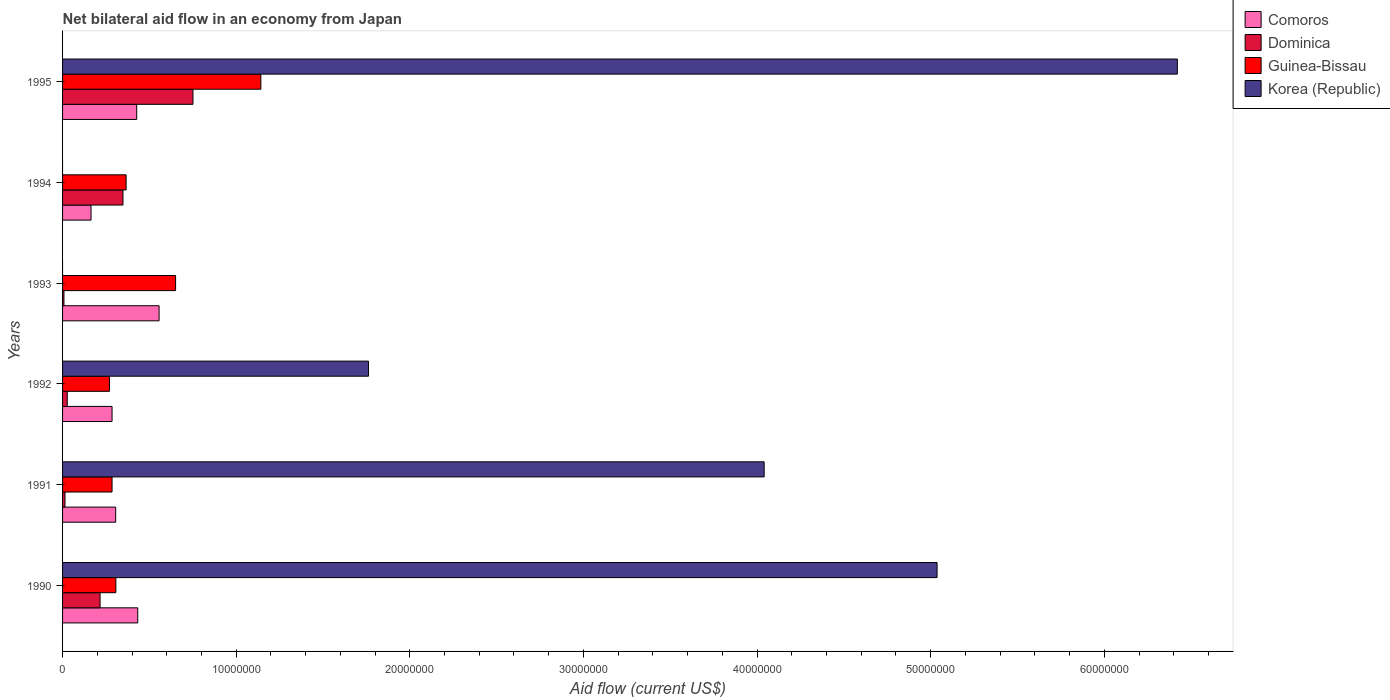Are the number of bars on each tick of the Y-axis equal?
Ensure brevity in your answer.  No. What is the label of the 1st group of bars from the top?
Offer a terse response. 1995. What is the net bilateral aid flow in Korea (Republic) in 1992?
Provide a short and direct response. 1.76e+07. Across all years, what is the maximum net bilateral aid flow in Comoros?
Your answer should be compact. 5.56e+06. In which year was the net bilateral aid flow in Comoros maximum?
Provide a short and direct response. 1993. What is the total net bilateral aid flow in Guinea-Bissau in the graph?
Make the answer very short. 3.02e+07. What is the difference between the net bilateral aid flow in Comoros in 1990 and that in 1993?
Keep it short and to the point. -1.23e+06. What is the difference between the net bilateral aid flow in Comoros in 1992 and the net bilateral aid flow in Dominica in 1994?
Your answer should be very brief. -6.30e+05. What is the average net bilateral aid flow in Guinea-Bissau per year?
Give a very brief answer. 5.04e+06. In the year 1991, what is the difference between the net bilateral aid flow in Dominica and net bilateral aid flow in Guinea-Bissau?
Give a very brief answer. -2.71e+06. What is the ratio of the net bilateral aid flow in Guinea-Bissau in 1991 to that in 1995?
Give a very brief answer. 0.25. Is the net bilateral aid flow in Comoros in 1992 less than that in 1993?
Offer a terse response. Yes. Is the difference between the net bilateral aid flow in Dominica in 1992 and 1995 greater than the difference between the net bilateral aid flow in Guinea-Bissau in 1992 and 1995?
Keep it short and to the point. Yes. What is the difference between the highest and the second highest net bilateral aid flow in Dominica?
Offer a terse response. 4.03e+06. What is the difference between the highest and the lowest net bilateral aid flow in Guinea-Bissau?
Give a very brief answer. 8.72e+06. In how many years, is the net bilateral aid flow in Dominica greater than the average net bilateral aid flow in Dominica taken over all years?
Ensure brevity in your answer.  2. How many bars are there?
Your response must be concise. 22. What is the difference between two consecutive major ticks on the X-axis?
Provide a succinct answer. 1.00e+07. Does the graph contain grids?
Your answer should be very brief. No. How many legend labels are there?
Your answer should be very brief. 4. What is the title of the graph?
Provide a short and direct response. Net bilateral aid flow in an economy from Japan. What is the label or title of the Y-axis?
Offer a terse response. Years. What is the Aid flow (current US$) in Comoros in 1990?
Your answer should be compact. 4.33e+06. What is the Aid flow (current US$) of Dominica in 1990?
Ensure brevity in your answer.  2.16e+06. What is the Aid flow (current US$) in Guinea-Bissau in 1990?
Keep it short and to the point. 3.07e+06. What is the Aid flow (current US$) of Korea (Republic) in 1990?
Your answer should be very brief. 5.04e+07. What is the Aid flow (current US$) of Comoros in 1991?
Ensure brevity in your answer.  3.06e+06. What is the Aid flow (current US$) of Dominica in 1991?
Provide a short and direct response. 1.40e+05. What is the Aid flow (current US$) of Guinea-Bissau in 1991?
Provide a short and direct response. 2.85e+06. What is the Aid flow (current US$) in Korea (Republic) in 1991?
Offer a terse response. 4.04e+07. What is the Aid flow (current US$) of Comoros in 1992?
Provide a succinct answer. 2.85e+06. What is the Aid flow (current US$) in Guinea-Bissau in 1992?
Make the answer very short. 2.70e+06. What is the Aid flow (current US$) in Korea (Republic) in 1992?
Provide a short and direct response. 1.76e+07. What is the Aid flow (current US$) in Comoros in 1993?
Your response must be concise. 5.56e+06. What is the Aid flow (current US$) of Dominica in 1993?
Provide a succinct answer. 8.00e+04. What is the Aid flow (current US$) in Guinea-Bissau in 1993?
Provide a short and direct response. 6.51e+06. What is the Aid flow (current US$) in Comoros in 1994?
Keep it short and to the point. 1.64e+06. What is the Aid flow (current US$) in Dominica in 1994?
Your answer should be compact. 3.48e+06. What is the Aid flow (current US$) in Guinea-Bissau in 1994?
Your answer should be compact. 3.66e+06. What is the Aid flow (current US$) in Comoros in 1995?
Provide a short and direct response. 4.27e+06. What is the Aid flow (current US$) in Dominica in 1995?
Keep it short and to the point. 7.51e+06. What is the Aid flow (current US$) in Guinea-Bissau in 1995?
Ensure brevity in your answer.  1.14e+07. What is the Aid flow (current US$) of Korea (Republic) in 1995?
Offer a terse response. 6.42e+07. Across all years, what is the maximum Aid flow (current US$) of Comoros?
Give a very brief answer. 5.56e+06. Across all years, what is the maximum Aid flow (current US$) of Dominica?
Your response must be concise. 7.51e+06. Across all years, what is the maximum Aid flow (current US$) in Guinea-Bissau?
Make the answer very short. 1.14e+07. Across all years, what is the maximum Aid flow (current US$) of Korea (Republic)?
Ensure brevity in your answer.  6.42e+07. Across all years, what is the minimum Aid flow (current US$) of Comoros?
Make the answer very short. 1.64e+06. Across all years, what is the minimum Aid flow (current US$) of Dominica?
Keep it short and to the point. 8.00e+04. Across all years, what is the minimum Aid flow (current US$) of Guinea-Bissau?
Ensure brevity in your answer.  2.70e+06. Across all years, what is the minimum Aid flow (current US$) of Korea (Republic)?
Provide a succinct answer. 0. What is the total Aid flow (current US$) of Comoros in the graph?
Offer a terse response. 2.17e+07. What is the total Aid flow (current US$) in Dominica in the graph?
Provide a succinct answer. 1.36e+07. What is the total Aid flow (current US$) in Guinea-Bissau in the graph?
Offer a terse response. 3.02e+07. What is the total Aid flow (current US$) of Korea (Republic) in the graph?
Your response must be concise. 1.73e+08. What is the difference between the Aid flow (current US$) in Comoros in 1990 and that in 1991?
Make the answer very short. 1.27e+06. What is the difference between the Aid flow (current US$) of Dominica in 1990 and that in 1991?
Your response must be concise. 2.02e+06. What is the difference between the Aid flow (current US$) of Guinea-Bissau in 1990 and that in 1991?
Give a very brief answer. 2.20e+05. What is the difference between the Aid flow (current US$) of Korea (Republic) in 1990 and that in 1991?
Offer a terse response. 9.96e+06. What is the difference between the Aid flow (current US$) of Comoros in 1990 and that in 1992?
Ensure brevity in your answer.  1.48e+06. What is the difference between the Aid flow (current US$) of Dominica in 1990 and that in 1992?
Keep it short and to the point. 1.89e+06. What is the difference between the Aid flow (current US$) of Guinea-Bissau in 1990 and that in 1992?
Provide a succinct answer. 3.70e+05. What is the difference between the Aid flow (current US$) of Korea (Republic) in 1990 and that in 1992?
Provide a short and direct response. 3.28e+07. What is the difference between the Aid flow (current US$) in Comoros in 1990 and that in 1993?
Ensure brevity in your answer.  -1.23e+06. What is the difference between the Aid flow (current US$) in Dominica in 1990 and that in 1993?
Offer a very short reply. 2.08e+06. What is the difference between the Aid flow (current US$) in Guinea-Bissau in 1990 and that in 1993?
Your response must be concise. -3.44e+06. What is the difference between the Aid flow (current US$) of Comoros in 1990 and that in 1994?
Make the answer very short. 2.69e+06. What is the difference between the Aid flow (current US$) in Dominica in 1990 and that in 1994?
Offer a terse response. -1.32e+06. What is the difference between the Aid flow (current US$) in Guinea-Bissau in 1990 and that in 1994?
Offer a terse response. -5.90e+05. What is the difference between the Aid flow (current US$) of Dominica in 1990 and that in 1995?
Provide a succinct answer. -5.35e+06. What is the difference between the Aid flow (current US$) in Guinea-Bissau in 1990 and that in 1995?
Offer a terse response. -8.35e+06. What is the difference between the Aid flow (current US$) of Korea (Republic) in 1990 and that in 1995?
Your answer should be compact. -1.38e+07. What is the difference between the Aid flow (current US$) in Comoros in 1991 and that in 1992?
Your response must be concise. 2.10e+05. What is the difference between the Aid flow (current US$) of Korea (Republic) in 1991 and that in 1992?
Your answer should be compact. 2.28e+07. What is the difference between the Aid flow (current US$) in Comoros in 1991 and that in 1993?
Your answer should be compact. -2.50e+06. What is the difference between the Aid flow (current US$) of Dominica in 1991 and that in 1993?
Your answer should be very brief. 6.00e+04. What is the difference between the Aid flow (current US$) of Guinea-Bissau in 1991 and that in 1993?
Keep it short and to the point. -3.66e+06. What is the difference between the Aid flow (current US$) of Comoros in 1991 and that in 1994?
Provide a short and direct response. 1.42e+06. What is the difference between the Aid flow (current US$) of Dominica in 1991 and that in 1994?
Your answer should be compact. -3.34e+06. What is the difference between the Aid flow (current US$) in Guinea-Bissau in 1991 and that in 1994?
Make the answer very short. -8.10e+05. What is the difference between the Aid flow (current US$) of Comoros in 1991 and that in 1995?
Offer a very short reply. -1.21e+06. What is the difference between the Aid flow (current US$) of Dominica in 1991 and that in 1995?
Ensure brevity in your answer.  -7.37e+06. What is the difference between the Aid flow (current US$) in Guinea-Bissau in 1991 and that in 1995?
Offer a very short reply. -8.57e+06. What is the difference between the Aid flow (current US$) in Korea (Republic) in 1991 and that in 1995?
Offer a very short reply. -2.38e+07. What is the difference between the Aid flow (current US$) of Comoros in 1992 and that in 1993?
Make the answer very short. -2.71e+06. What is the difference between the Aid flow (current US$) of Dominica in 1992 and that in 1993?
Offer a terse response. 1.90e+05. What is the difference between the Aid flow (current US$) of Guinea-Bissau in 1992 and that in 1993?
Provide a short and direct response. -3.81e+06. What is the difference between the Aid flow (current US$) in Comoros in 1992 and that in 1994?
Provide a short and direct response. 1.21e+06. What is the difference between the Aid flow (current US$) of Dominica in 1992 and that in 1994?
Make the answer very short. -3.21e+06. What is the difference between the Aid flow (current US$) in Guinea-Bissau in 1992 and that in 1994?
Your response must be concise. -9.60e+05. What is the difference between the Aid flow (current US$) of Comoros in 1992 and that in 1995?
Your answer should be very brief. -1.42e+06. What is the difference between the Aid flow (current US$) in Dominica in 1992 and that in 1995?
Provide a succinct answer. -7.24e+06. What is the difference between the Aid flow (current US$) in Guinea-Bissau in 1992 and that in 1995?
Offer a very short reply. -8.72e+06. What is the difference between the Aid flow (current US$) of Korea (Republic) in 1992 and that in 1995?
Offer a very short reply. -4.66e+07. What is the difference between the Aid flow (current US$) in Comoros in 1993 and that in 1994?
Keep it short and to the point. 3.92e+06. What is the difference between the Aid flow (current US$) of Dominica in 1993 and that in 1994?
Your response must be concise. -3.40e+06. What is the difference between the Aid flow (current US$) of Guinea-Bissau in 1993 and that in 1994?
Provide a succinct answer. 2.85e+06. What is the difference between the Aid flow (current US$) of Comoros in 1993 and that in 1995?
Provide a short and direct response. 1.29e+06. What is the difference between the Aid flow (current US$) of Dominica in 1993 and that in 1995?
Provide a succinct answer. -7.43e+06. What is the difference between the Aid flow (current US$) of Guinea-Bissau in 1993 and that in 1995?
Offer a very short reply. -4.91e+06. What is the difference between the Aid flow (current US$) in Comoros in 1994 and that in 1995?
Provide a short and direct response. -2.63e+06. What is the difference between the Aid flow (current US$) in Dominica in 1994 and that in 1995?
Provide a succinct answer. -4.03e+06. What is the difference between the Aid flow (current US$) in Guinea-Bissau in 1994 and that in 1995?
Provide a short and direct response. -7.76e+06. What is the difference between the Aid flow (current US$) in Comoros in 1990 and the Aid flow (current US$) in Dominica in 1991?
Ensure brevity in your answer.  4.19e+06. What is the difference between the Aid flow (current US$) in Comoros in 1990 and the Aid flow (current US$) in Guinea-Bissau in 1991?
Give a very brief answer. 1.48e+06. What is the difference between the Aid flow (current US$) in Comoros in 1990 and the Aid flow (current US$) in Korea (Republic) in 1991?
Provide a short and direct response. -3.61e+07. What is the difference between the Aid flow (current US$) in Dominica in 1990 and the Aid flow (current US$) in Guinea-Bissau in 1991?
Provide a succinct answer. -6.90e+05. What is the difference between the Aid flow (current US$) of Dominica in 1990 and the Aid flow (current US$) of Korea (Republic) in 1991?
Provide a succinct answer. -3.82e+07. What is the difference between the Aid flow (current US$) in Guinea-Bissau in 1990 and the Aid flow (current US$) in Korea (Republic) in 1991?
Offer a very short reply. -3.73e+07. What is the difference between the Aid flow (current US$) in Comoros in 1990 and the Aid flow (current US$) in Dominica in 1992?
Your answer should be compact. 4.06e+06. What is the difference between the Aid flow (current US$) in Comoros in 1990 and the Aid flow (current US$) in Guinea-Bissau in 1992?
Provide a short and direct response. 1.63e+06. What is the difference between the Aid flow (current US$) in Comoros in 1990 and the Aid flow (current US$) in Korea (Republic) in 1992?
Provide a succinct answer. -1.33e+07. What is the difference between the Aid flow (current US$) in Dominica in 1990 and the Aid flow (current US$) in Guinea-Bissau in 1992?
Provide a succinct answer. -5.40e+05. What is the difference between the Aid flow (current US$) of Dominica in 1990 and the Aid flow (current US$) of Korea (Republic) in 1992?
Make the answer very short. -1.55e+07. What is the difference between the Aid flow (current US$) of Guinea-Bissau in 1990 and the Aid flow (current US$) of Korea (Republic) in 1992?
Make the answer very short. -1.46e+07. What is the difference between the Aid flow (current US$) in Comoros in 1990 and the Aid flow (current US$) in Dominica in 1993?
Your answer should be compact. 4.25e+06. What is the difference between the Aid flow (current US$) of Comoros in 1990 and the Aid flow (current US$) of Guinea-Bissau in 1993?
Keep it short and to the point. -2.18e+06. What is the difference between the Aid flow (current US$) of Dominica in 1990 and the Aid flow (current US$) of Guinea-Bissau in 1993?
Your answer should be compact. -4.35e+06. What is the difference between the Aid flow (current US$) of Comoros in 1990 and the Aid flow (current US$) of Dominica in 1994?
Keep it short and to the point. 8.50e+05. What is the difference between the Aid flow (current US$) of Comoros in 1990 and the Aid flow (current US$) of Guinea-Bissau in 1994?
Make the answer very short. 6.70e+05. What is the difference between the Aid flow (current US$) in Dominica in 1990 and the Aid flow (current US$) in Guinea-Bissau in 1994?
Make the answer very short. -1.50e+06. What is the difference between the Aid flow (current US$) of Comoros in 1990 and the Aid flow (current US$) of Dominica in 1995?
Your answer should be very brief. -3.18e+06. What is the difference between the Aid flow (current US$) in Comoros in 1990 and the Aid flow (current US$) in Guinea-Bissau in 1995?
Ensure brevity in your answer.  -7.09e+06. What is the difference between the Aid flow (current US$) in Comoros in 1990 and the Aid flow (current US$) in Korea (Republic) in 1995?
Provide a short and direct response. -5.99e+07. What is the difference between the Aid flow (current US$) in Dominica in 1990 and the Aid flow (current US$) in Guinea-Bissau in 1995?
Offer a very short reply. -9.26e+06. What is the difference between the Aid flow (current US$) in Dominica in 1990 and the Aid flow (current US$) in Korea (Republic) in 1995?
Your response must be concise. -6.20e+07. What is the difference between the Aid flow (current US$) in Guinea-Bissau in 1990 and the Aid flow (current US$) in Korea (Republic) in 1995?
Provide a succinct answer. -6.11e+07. What is the difference between the Aid flow (current US$) in Comoros in 1991 and the Aid flow (current US$) in Dominica in 1992?
Make the answer very short. 2.79e+06. What is the difference between the Aid flow (current US$) of Comoros in 1991 and the Aid flow (current US$) of Guinea-Bissau in 1992?
Your answer should be compact. 3.60e+05. What is the difference between the Aid flow (current US$) of Comoros in 1991 and the Aid flow (current US$) of Korea (Republic) in 1992?
Offer a very short reply. -1.46e+07. What is the difference between the Aid flow (current US$) in Dominica in 1991 and the Aid flow (current US$) in Guinea-Bissau in 1992?
Ensure brevity in your answer.  -2.56e+06. What is the difference between the Aid flow (current US$) in Dominica in 1991 and the Aid flow (current US$) in Korea (Republic) in 1992?
Offer a very short reply. -1.75e+07. What is the difference between the Aid flow (current US$) of Guinea-Bissau in 1991 and the Aid flow (current US$) of Korea (Republic) in 1992?
Ensure brevity in your answer.  -1.48e+07. What is the difference between the Aid flow (current US$) in Comoros in 1991 and the Aid flow (current US$) in Dominica in 1993?
Your answer should be very brief. 2.98e+06. What is the difference between the Aid flow (current US$) of Comoros in 1991 and the Aid flow (current US$) of Guinea-Bissau in 1993?
Provide a succinct answer. -3.45e+06. What is the difference between the Aid flow (current US$) of Dominica in 1991 and the Aid flow (current US$) of Guinea-Bissau in 1993?
Give a very brief answer. -6.37e+06. What is the difference between the Aid flow (current US$) of Comoros in 1991 and the Aid flow (current US$) of Dominica in 1994?
Keep it short and to the point. -4.20e+05. What is the difference between the Aid flow (current US$) of Comoros in 1991 and the Aid flow (current US$) of Guinea-Bissau in 1994?
Provide a short and direct response. -6.00e+05. What is the difference between the Aid flow (current US$) in Dominica in 1991 and the Aid flow (current US$) in Guinea-Bissau in 1994?
Give a very brief answer. -3.52e+06. What is the difference between the Aid flow (current US$) of Comoros in 1991 and the Aid flow (current US$) of Dominica in 1995?
Your answer should be compact. -4.45e+06. What is the difference between the Aid flow (current US$) of Comoros in 1991 and the Aid flow (current US$) of Guinea-Bissau in 1995?
Make the answer very short. -8.36e+06. What is the difference between the Aid flow (current US$) of Comoros in 1991 and the Aid flow (current US$) of Korea (Republic) in 1995?
Ensure brevity in your answer.  -6.12e+07. What is the difference between the Aid flow (current US$) of Dominica in 1991 and the Aid flow (current US$) of Guinea-Bissau in 1995?
Offer a terse response. -1.13e+07. What is the difference between the Aid flow (current US$) in Dominica in 1991 and the Aid flow (current US$) in Korea (Republic) in 1995?
Your answer should be compact. -6.41e+07. What is the difference between the Aid flow (current US$) in Guinea-Bissau in 1991 and the Aid flow (current US$) in Korea (Republic) in 1995?
Make the answer very short. -6.14e+07. What is the difference between the Aid flow (current US$) in Comoros in 1992 and the Aid flow (current US$) in Dominica in 1993?
Keep it short and to the point. 2.77e+06. What is the difference between the Aid flow (current US$) in Comoros in 1992 and the Aid flow (current US$) in Guinea-Bissau in 1993?
Offer a very short reply. -3.66e+06. What is the difference between the Aid flow (current US$) of Dominica in 1992 and the Aid flow (current US$) of Guinea-Bissau in 1993?
Provide a succinct answer. -6.24e+06. What is the difference between the Aid flow (current US$) in Comoros in 1992 and the Aid flow (current US$) in Dominica in 1994?
Offer a very short reply. -6.30e+05. What is the difference between the Aid flow (current US$) of Comoros in 1992 and the Aid flow (current US$) of Guinea-Bissau in 1994?
Ensure brevity in your answer.  -8.10e+05. What is the difference between the Aid flow (current US$) of Dominica in 1992 and the Aid flow (current US$) of Guinea-Bissau in 1994?
Offer a very short reply. -3.39e+06. What is the difference between the Aid flow (current US$) of Comoros in 1992 and the Aid flow (current US$) of Dominica in 1995?
Provide a short and direct response. -4.66e+06. What is the difference between the Aid flow (current US$) of Comoros in 1992 and the Aid flow (current US$) of Guinea-Bissau in 1995?
Provide a succinct answer. -8.57e+06. What is the difference between the Aid flow (current US$) of Comoros in 1992 and the Aid flow (current US$) of Korea (Republic) in 1995?
Offer a terse response. -6.14e+07. What is the difference between the Aid flow (current US$) in Dominica in 1992 and the Aid flow (current US$) in Guinea-Bissau in 1995?
Keep it short and to the point. -1.12e+07. What is the difference between the Aid flow (current US$) of Dominica in 1992 and the Aid flow (current US$) of Korea (Republic) in 1995?
Provide a succinct answer. -6.39e+07. What is the difference between the Aid flow (current US$) in Guinea-Bissau in 1992 and the Aid flow (current US$) in Korea (Republic) in 1995?
Keep it short and to the point. -6.15e+07. What is the difference between the Aid flow (current US$) in Comoros in 1993 and the Aid flow (current US$) in Dominica in 1994?
Provide a succinct answer. 2.08e+06. What is the difference between the Aid flow (current US$) in Comoros in 1993 and the Aid flow (current US$) in Guinea-Bissau in 1994?
Offer a terse response. 1.90e+06. What is the difference between the Aid flow (current US$) of Dominica in 1993 and the Aid flow (current US$) of Guinea-Bissau in 1994?
Provide a short and direct response. -3.58e+06. What is the difference between the Aid flow (current US$) in Comoros in 1993 and the Aid flow (current US$) in Dominica in 1995?
Your answer should be very brief. -1.95e+06. What is the difference between the Aid flow (current US$) of Comoros in 1993 and the Aid flow (current US$) of Guinea-Bissau in 1995?
Your answer should be compact. -5.86e+06. What is the difference between the Aid flow (current US$) of Comoros in 1993 and the Aid flow (current US$) of Korea (Republic) in 1995?
Your answer should be very brief. -5.86e+07. What is the difference between the Aid flow (current US$) of Dominica in 1993 and the Aid flow (current US$) of Guinea-Bissau in 1995?
Offer a very short reply. -1.13e+07. What is the difference between the Aid flow (current US$) in Dominica in 1993 and the Aid flow (current US$) in Korea (Republic) in 1995?
Your answer should be very brief. -6.41e+07. What is the difference between the Aid flow (current US$) of Guinea-Bissau in 1993 and the Aid flow (current US$) of Korea (Republic) in 1995?
Your response must be concise. -5.77e+07. What is the difference between the Aid flow (current US$) in Comoros in 1994 and the Aid flow (current US$) in Dominica in 1995?
Provide a short and direct response. -5.87e+06. What is the difference between the Aid flow (current US$) in Comoros in 1994 and the Aid flow (current US$) in Guinea-Bissau in 1995?
Your response must be concise. -9.78e+06. What is the difference between the Aid flow (current US$) of Comoros in 1994 and the Aid flow (current US$) of Korea (Republic) in 1995?
Your response must be concise. -6.26e+07. What is the difference between the Aid flow (current US$) of Dominica in 1994 and the Aid flow (current US$) of Guinea-Bissau in 1995?
Provide a short and direct response. -7.94e+06. What is the difference between the Aid flow (current US$) of Dominica in 1994 and the Aid flow (current US$) of Korea (Republic) in 1995?
Make the answer very short. -6.07e+07. What is the difference between the Aid flow (current US$) in Guinea-Bissau in 1994 and the Aid flow (current US$) in Korea (Republic) in 1995?
Offer a very short reply. -6.06e+07. What is the average Aid flow (current US$) of Comoros per year?
Your answer should be very brief. 3.62e+06. What is the average Aid flow (current US$) of Dominica per year?
Provide a short and direct response. 2.27e+06. What is the average Aid flow (current US$) in Guinea-Bissau per year?
Give a very brief answer. 5.04e+06. What is the average Aid flow (current US$) in Korea (Republic) per year?
Keep it short and to the point. 2.88e+07. In the year 1990, what is the difference between the Aid flow (current US$) of Comoros and Aid flow (current US$) of Dominica?
Keep it short and to the point. 2.17e+06. In the year 1990, what is the difference between the Aid flow (current US$) in Comoros and Aid flow (current US$) in Guinea-Bissau?
Make the answer very short. 1.26e+06. In the year 1990, what is the difference between the Aid flow (current US$) in Comoros and Aid flow (current US$) in Korea (Republic)?
Offer a very short reply. -4.60e+07. In the year 1990, what is the difference between the Aid flow (current US$) in Dominica and Aid flow (current US$) in Guinea-Bissau?
Make the answer very short. -9.10e+05. In the year 1990, what is the difference between the Aid flow (current US$) in Dominica and Aid flow (current US$) in Korea (Republic)?
Offer a terse response. -4.82e+07. In the year 1990, what is the difference between the Aid flow (current US$) in Guinea-Bissau and Aid flow (current US$) in Korea (Republic)?
Your response must be concise. -4.73e+07. In the year 1991, what is the difference between the Aid flow (current US$) of Comoros and Aid flow (current US$) of Dominica?
Offer a very short reply. 2.92e+06. In the year 1991, what is the difference between the Aid flow (current US$) in Comoros and Aid flow (current US$) in Guinea-Bissau?
Provide a succinct answer. 2.10e+05. In the year 1991, what is the difference between the Aid flow (current US$) of Comoros and Aid flow (current US$) of Korea (Republic)?
Offer a terse response. -3.74e+07. In the year 1991, what is the difference between the Aid flow (current US$) of Dominica and Aid flow (current US$) of Guinea-Bissau?
Your answer should be compact. -2.71e+06. In the year 1991, what is the difference between the Aid flow (current US$) of Dominica and Aid flow (current US$) of Korea (Republic)?
Keep it short and to the point. -4.03e+07. In the year 1991, what is the difference between the Aid flow (current US$) of Guinea-Bissau and Aid flow (current US$) of Korea (Republic)?
Provide a succinct answer. -3.76e+07. In the year 1992, what is the difference between the Aid flow (current US$) of Comoros and Aid flow (current US$) of Dominica?
Your response must be concise. 2.58e+06. In the year 1992, what is the difference between the Aid flow (current US$) in Comoros and Aid flow (current US$) in Guinea-Bissau?
Your answer should be compact. 1.50e+05. In the year 1992, what is the difference between the Aid flow (current US$) in Comoros and Aid flow (current US$) in Korea (Republic)?
Ensure brevity in your answer.  -1.48e+07. In the year 1992, what is the difference between the Aid flow (current US$) in Dominica and Aid flow (current US$) in Guinea-Bissau?
Give a very brief answer. -2.43e+06. In the year 1992, what is the difference between the Aid flow (current US$) in Dominica and Aid flow (current US$) in Korea (Republic)?
Ensure brevity in your answer.  -1.74e+07. In the year 1992, what is the difference between the Aid flow (current US$) in Guinea-Bissau and Aid flow (current US$) in Korea (Republic)?
Offer a very short reply. -1.49e+07. In the year 1993, what is the difference between the Aid flow (current US$) in Comoros and Aid flow (current US$) in Dominica?
Make the answer very short. 5.48e+06. In the year 1993, what is the difference between the Aid flow (current US$) of Comoros and Aid flow (current US$) of Guinea-Bissau?
Provide a short and direct response. -9.50e+05. In the year 1993, what is the difference between the Aid flow (current US$) in Dominica and Aid flow (current US$) in Guinea-Bissau?
Give a very brief answer. -6.43e+06. In the year 1994, what is the difference between the Aid flow (current US$) in Comoros and Aid flow (current US$) in Dominica?
Provide a short and direct response. -1.84e+06. In the year 1994, what is the difference between the Aid flow (current US$) of Comoros and Aid flow (current US$) of Guinea-Bissau?
Your response must be concise. -2.02e+06. In the year 1995, what is the difference between the Aid flow (current US$) in Comoros and Aid flow (current US$) in Dominica?
Provide a short and direct response. -3.24e+06. In the year 1995, what is the difference between the Aid flow (current US$) in Comoros and Aid flow (current US$) in Guinea-Bissau?
Make the answer very short. -7.15e+06. In the year 1995, what is the difference between the Aid flow (current US$) in Comoros and Aid flow (current US$) in Korea (Republic)?
Give a very brief answer. -5.99e+07. In the year 1995, what is the difference between the Aid flow (current US$) in Dominica and Aid flow (current US$) in Guinea-Bissau?
Provide a short and direct response. -3.91e+06. In the year 1995, what is the difference between the Aid flow (current US$) of Dominica and Aid flow (current US$) of Korea (Republic)?
Provide a short and direct response. -5.67e+07. In the year 1995, what is the difference between the Aid flow (current US$) of Guinea-Bissau and Aid flow (current US$) of Korea (Republic)?
Offer a terse response. -5.28e+07. What is the ratio of the Aid flow (current US$) in Comoros in 1990 to that in 1991?
Offer a terse response. 1.42. What is the ratio of the Aid flow (current US$) in Dominica in 1990 to that in 1991?
Your answer should be very brief. 15.43. What is the ratio of the Aid flow (current US$) of Guinea-Bissau in 1990 to that in 1991?
Offer a very short reply. 1.08. What is the ratio of the Aid flow (current US$) in Korea (Republic) in 1990 to that in 1991?
Your answer should be very brief. 1.25. What is the ratio of the Aid flow (current US$) of Comoros in 1990 to that in 1992?
Offer a terse response. 1.52. What is the ratio of the Aid flow (current US$) of Guinea-Bissau in 1990 to that in 1992?
Your answer should be very brief. 1.14. What is the ratio of the Aid flow (current US$) of Korea (Republic) in 1990 to that in 1992?
Keep it short and to the point. 2.86. What is the ratio of the Aid flow (current US$) in Comoros in 1990 to that in 1993?
Your answer should be very brief. 0.78. What is the ratio of the Aid flow (current US$) in Dominica in 1990 to that in 1993?
Make the answer very short. 27. What is the ratio of the Aid flow (current US$) in Guinea-Bissau in 1990 to that in 1993?
Give a very brief answer. 0.47. What is the ratio of the Aid flow (current US$) of Comoros in 1990 to that in 1994?
Provide a short and direct response. 2.64. What is the ratio of the Aid flow (current US$) of Dominica in 1990 to that in 1994?
Offer a very short reply. 0.62. What is the ratio of the Aid flow (current US$) in Guinea-Bissau in 1990 to that in 1994?
Make the answer very short. 0.84. What is the ratio of the Aid flow (current US$) in Comoros in 1990 to that in 1995?
Provide a succinct answer. 1.01. What is the ratio of the Aid flow (current US$) of Dominica in 1990 to that in 1995?
Provide a succinct answer. 0.29. What is the ratio of the Aid flow (current US$) in Guinea-Bissau in 1990 to that in 1995?
Give a very brief answer. 0.27. What is the ratio of the Aid flow (current US$) of Korea (Republic) in 1990 to that in 1995?
Give a very brief answer. 0.78. What is the ratio of the Aid flow (current US$) in Comoros in 1991 to that in 1992?
Your response must be concise. 1.07. What is the ratio of the Aid flow (current US$) of Dominica in 1991 to that in 1992?
Give a very brief answer. 0.52. What is the ratio of the Aid flow (current US$) of Guinea-Bissau in 1991 to that in 1992?
Your answer should be compact. 1.06. What is the ratio of the Aid flow (current US$) in Korea (Republic) in 1991 to that in 1992?
Your answer should be very brief. 2.29. What is the ratio of the Aid flow (current US$) of Comoros in 1991 to that in 1993?
Ensure brevity in your answer.  0.55. What is the ratio of the Aid flow (current US$) in Dominica in 1991 to that in 1993?
Provide a short and direct response. 1.75. What is the ratio of the Aid flow (current US$) in Guinea-Bissau in 1991 to that in 1993?
Provide a succinct answer. 0.44. What is the ratio of the Aid flow (current US$) of Comoros in 1991 to that in 1994?
Offer a terse response. 1.87. What is the ratio of the Aid flow (current US$) in Dominica in 1991 to that in 1994?
Provide a succinct answer. 0.04. What is the ratio of the Aid flow (current US$) in Guinea-Bissau in 1991 to that in 1994?
Provide a short and direct response. 0.78. What is the ratio of the Aid flow (current US$) in Comoros in 1991 to that in 1995?
Make the answer very short. 0.72. What is the ratio of the Aid flow (current US$) of Dominica in 1991 to that in 1995?
Offer a terse response. 0.02. What is the ratio of the Aid flow (current US$) in Guinea-Bissau in 1991 to that in 1995?
Keep it short and to the point. 0.25. What is the ratio of the Aid flow (current US$) of Korea (Republic) in 1991 to that in 1995?
Your response must be concise. 0.63. What is the ratio of the Aid flow (current US$) in Comoros in 1992 to that in 1993?
Ensure brevity in your answer.  0.51. What is the ratio of the Aid flow (current US$) of Dominica in 1992 to that in 1993?
Provide a succinct answer. 3.38. What is the ratio of the Aid flow (current US$) in Guinea-Bissau in 1992 to that in 1993?
Make the answer very short. 0.41. What is the ratio of the Aid flow (current US$) in Comoros in 1992 to that in 1994?
Provide a succinct answer. 1.74. What is the ratio of the Aid flow (current US$) in Dominica in 1992 to that in 1994?
Provide a short and direct response. 0.08. What is the ratio of the Aid flow (current US$) in Guinea-Bissau in 1992 to that in 1994?
Provide a succinct answer. 0.74. What is the ratio of the Aid flow (current US$) in Comoros in 1992 to that in 1995?
Provide a succinct answer. 0.67. What is the ratio of the Aid flow (current US$) of Dominica in 1992 to that in 1995?
Offer a terse response. 0.04. What is the ratio of the Aid flow (current US$) of Guinea-Bissau in 1992 to that in 1995?
Provide a succinct answer. 0.24. What is the ratio of the Aid flow (current US$) of Korea (Republic) in 1992 to that in 1995?
Ensure brevity in your answer.  0.27. What is the ratio of the Aid flow (current US$) in Comoros in 1993 to that in 1994?
Your answer should be very brief. 3.39. What is the ratio of the Aid flow (current US$) in Dominica in 1993 to that in 1994?
Make the answer very short. 0.02. What is the ratio of the Aid flow (current US$) of Guinea-Bissau in 1993 to that in 1994?
Ensure brevity in your answer.  1.78. What is the ratio of the Aid flow (current US$) of Comoros in 1993 to that in 1995?
Ensure brevity in your answer.  1.3. What is the ratio of the Aid flow (current US$) of Dominica in 1993 to that in 1995?
Your answer should be compact. 0.01. What is the ratio of the Aid flow (current US$) of Guinea-Bissau in 1993 to that in 1995?
Ensure brevity in your answer.  0.57. What is the ratio of the Aid flow (current US$) in Comoros in 1994 to that in 1995?
Keep it short and to the point. 0.38. What is the ratio of the Aid flow (current US$) of Dominica in 1994 to that in 1995?
Offer a terse response. 0.46. What is the ratio of the Aid flow (current US$) of Guinea-Bissau in 1994 to that in 1995?
Ensure brevity in your answer.  0.32. What is the difference between the highest and the second highest Aid flow (current US$) in Comoros?
Offer a very short reply. 1.23e+06. What is the difference between the highest and the second highest Aid flow (current US$) of Dominica?
Offer a terse response. 4.03e+06. What is the difference between the highest and the second highest Aid flow (current US$) of Guinea-Bissau?
Keep it short and to the point. 4.91e+06. What is the difference between the highest and the second highest Aid flow (current US$) in Korea (Republic)?
Offer a terse response. 1.38e+07. What is the difference between the highest and the lowest Aid flow (current US$) of Comoros?
Your response must be concise. 3.92e+06. What is the difference between the highest and the lowest Aid flow (current US$) in Dominica?
Give a very brief answer. 7.43e+06. What is the difference between the highest and the lowest Aid flow (current US$) in Guinea-Bissau?
Offer a very short reply. 8.72e+06. What is the difference between the highest and the lowest Aid flow (current US$) of Korea (Republic)?
Offer a very short reply. 6.42e+07. 